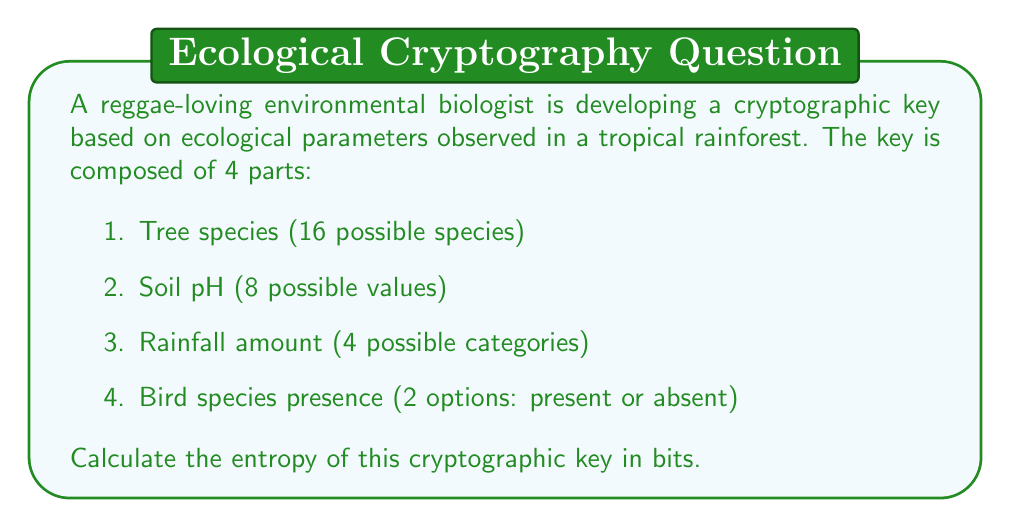Solve this math problem. To calculate the entropy of the cryptographic key, we need to follow these steps:

1. Determine the number of possible combinations for the key:
   $$ N = 16 \times 8 \times 4 \times 2 = 1024 $$

2. Calculate the entropy using the formula:
   $$ H = \log_2(N) $$

   Where $H$ is the entropy in bits, and $N$ is the number of possible combinations.

3. Substitute the value of $N$:
   $$ H = \log_2(1024) $$

4. Simplify:
   $$ H = 10 $$

   This is because $2^{10} = 1024$, so $\log_2(1024) = 10$.

Therefore, the entropy of the cryptographic key is 10 bits.

Note: In cryptography, higher entropy generally indicates a stronger key. However, 10 bits of entropy is considered very low for practical cryptographic applications. For secure cryptographic keys, much higher entropy values (e.g., 128 bits or more) are typically used.
Answer: 10 bits 